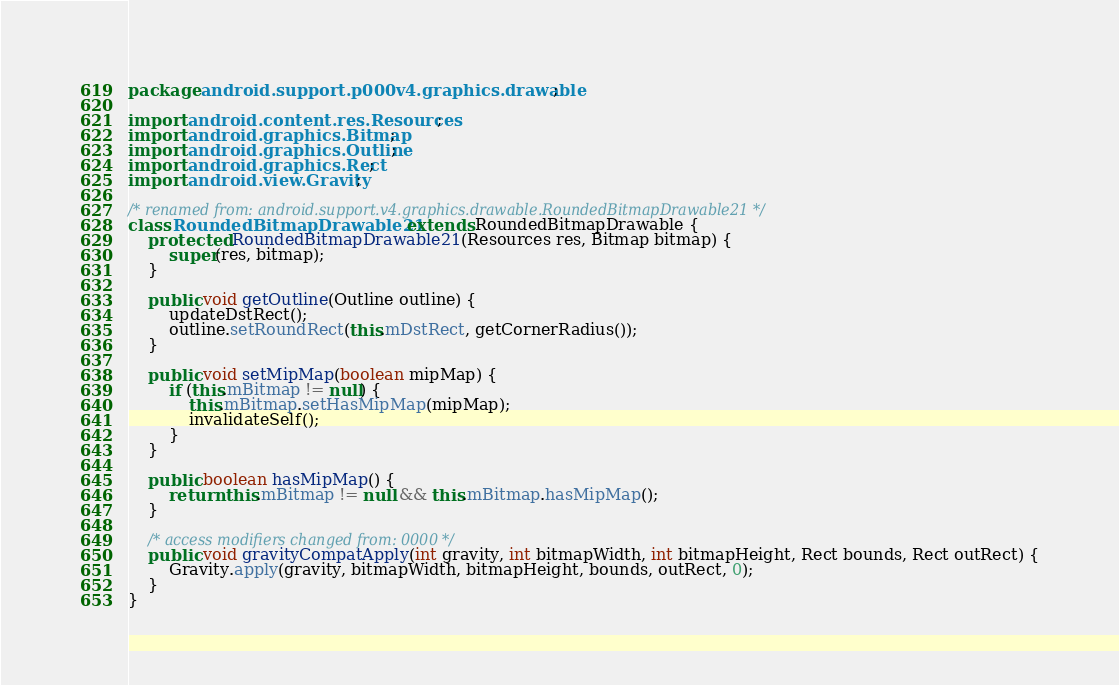<code> <loc_0><loc_0><loc_500><loc_500><_Java_>package android.support.p000v4.graphics.drawable;

import android.content.res.Resources;
import android.graphics.Bitmap;
import android.graphics.Outline;
import android.graphics.Rect;
import android.view.Gravity;

/* renamed from: android.support.v4.graphics.drawable.RoundedBitmapDrawable21 */
class RoundedBitmapDrawable21 extends RoundedBitmapDrawable {
    protected RoundedBitmapDrawable21(Resources res, Bitmap bitmap) {
        super(res, bitmap);
    }

    public void getOutline(Outline outline) {
        updateDstRect();
        outline.setRoundRect(this.mDstRect, getCornerRadius());
    }

    public void setMipMap(boolean mipMap) {
        if (this.mBitmap != null) {
            this.mBitmap.setHasMipMap(mipMap);
            invalidateSelf();
        }
    }

    public boolean hasMipMap() {
        return this.mBitmap != null && this.mBitmap.hasMipMap();
    }

    /* access modifiers changed from: 0000 */
    public void gravityCompatApply(int gravity, int bitmapWidth, int bitmapHeight, Rect bounds, Rect outRect) {
        Gravity.apply(gravity, bitmapWidth, bitmapHeight, bounds, outRect, 0);
    }
}
</code> 